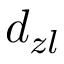<formula> <loc_0><loc_0><loc_500><loc_500>d _ { z l }</formula> 